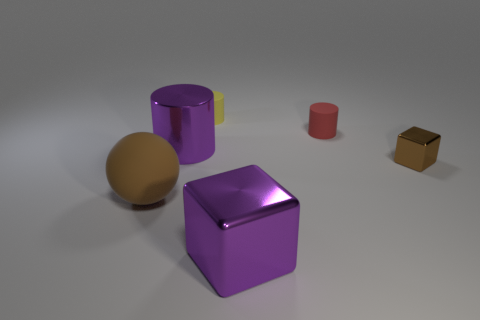Add 2 small yellow rubber cylinders. How many objects exist? 8 Subtract all blocks. How many objects are left? 4 Add 4 large green objects. How many large green objects exist? 4 Subtract 0 gray cylinders. How many objects are left? 6 Subtract all big cyan rubber cylinders. Subtract all purple cylinders. How many objects are left? 5 Add 4 tiny cylinders. How many tiny cylinders are left? 6 